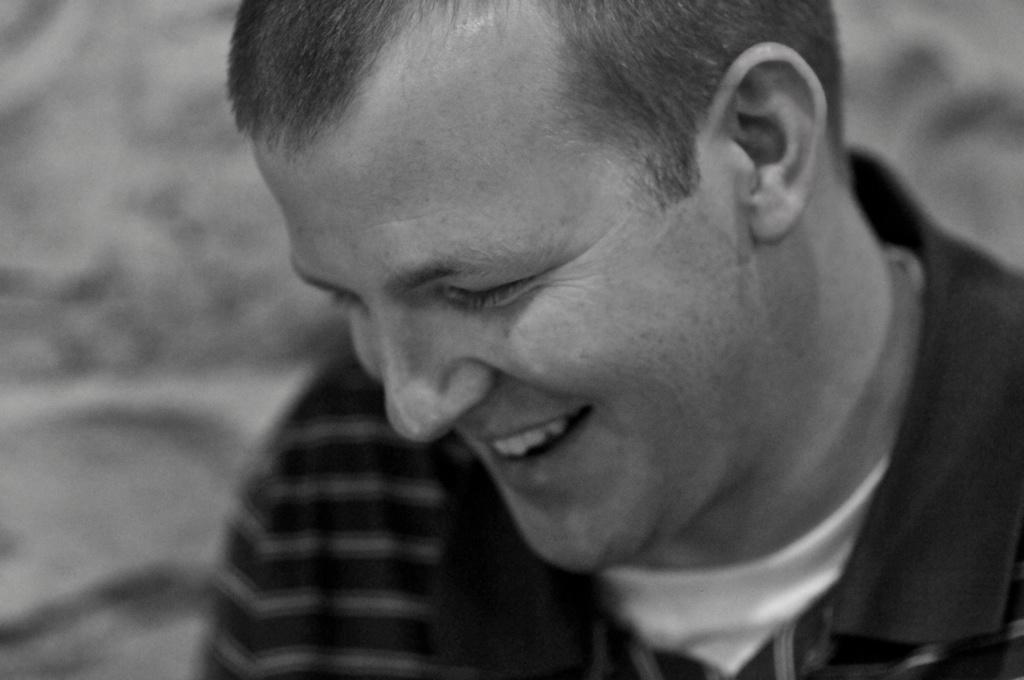Who is present in the image? There is a man in the image. What is the man's facial expression? The man is smiling. Can you describe the background of the image? The background of the image is blurred. What type of care does the man provide in the image? There is no indication in the image that the man is providing care, as the facts provided do not mention any care-related activities. 